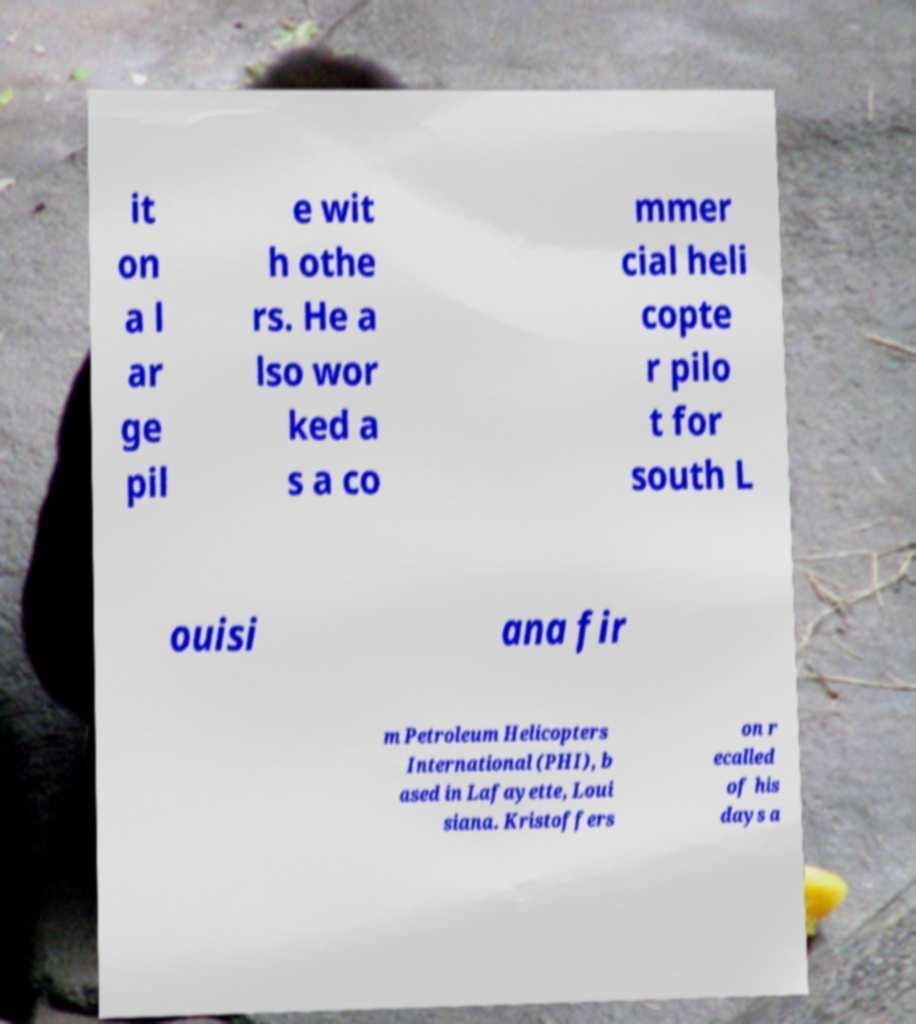Could you extract and type out the text from this image? it on a l ar ge pil e wit h othe rs. He a lso wor ked a s a co mmer cial heli copte r pilo t for south L ouisi ana fir m Petroleum Helicopters International (PHI), b ased in Lafayette, Loui siana. Kristoffers on r ecalled of his days a 